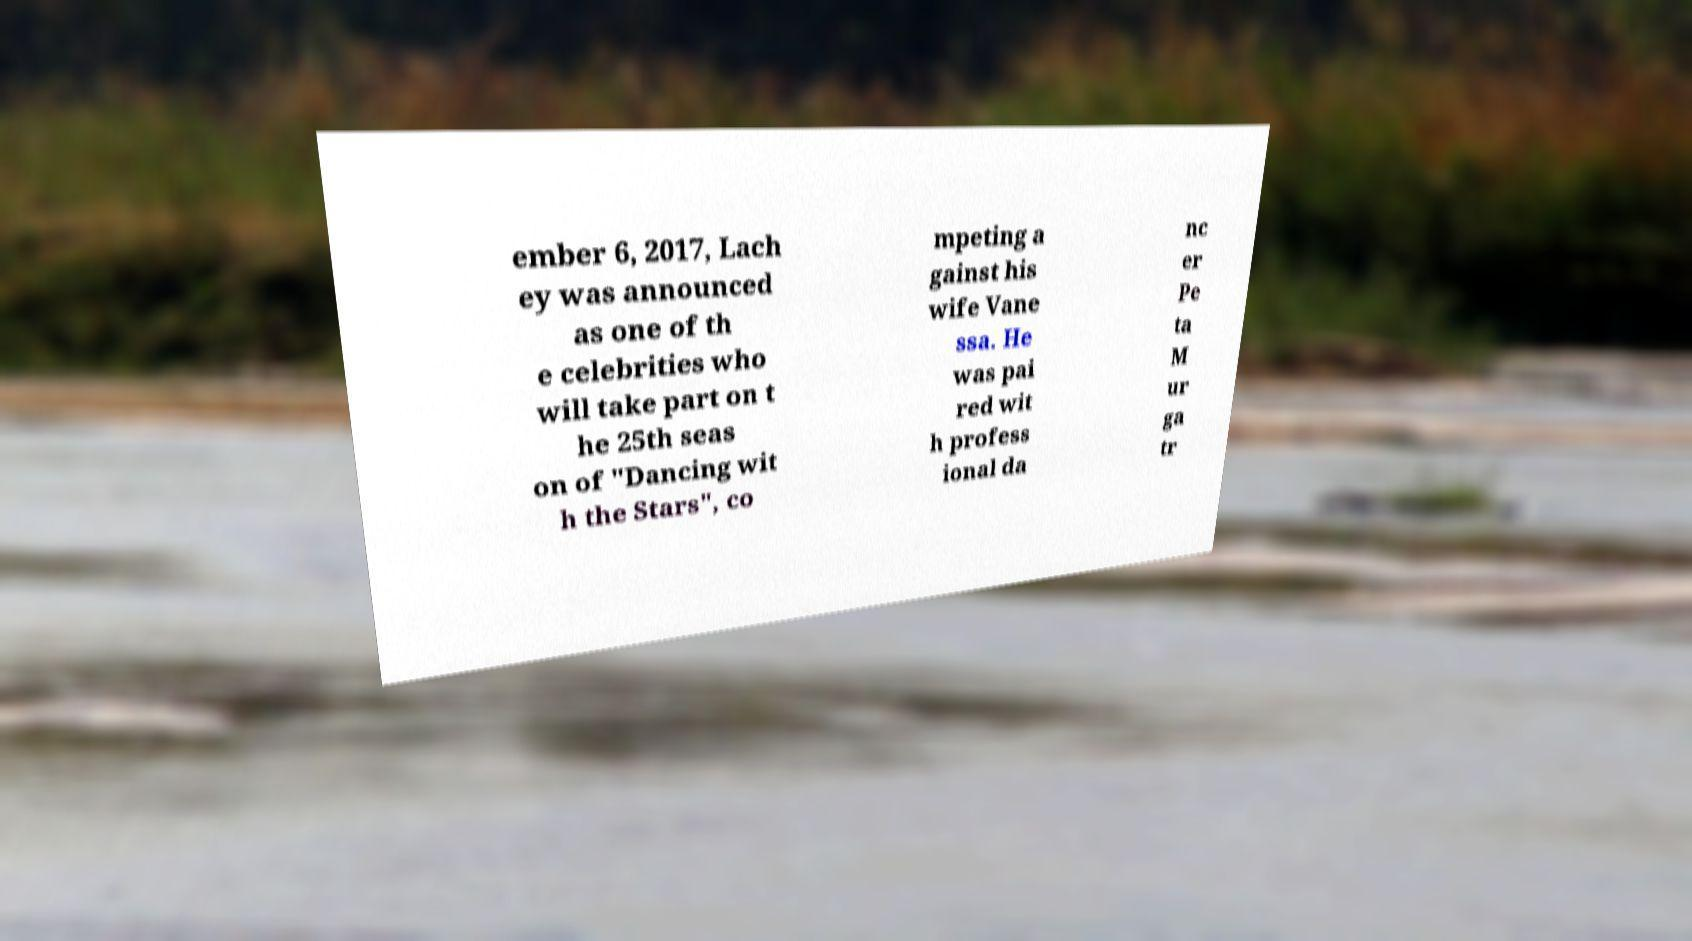What messages or text are displayed in this image? I need them in a readable, typed format. ember 6, 2017, Lach ey was announced as one of th e celebrities who will take part on t he 25th seas on of "Dancing wit h the Stars", co mpeting a gainst his wife Vane ssa. He was pai red wit h profess ional da nc er Pe ta M ur ga tr 